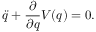Convert formula to latex. <formula><loc_0><loc_0><loc_500><loc_500>\ddot { q } + \frac { \partial } { \partial q } V ( q ) = 0 .</formula> 